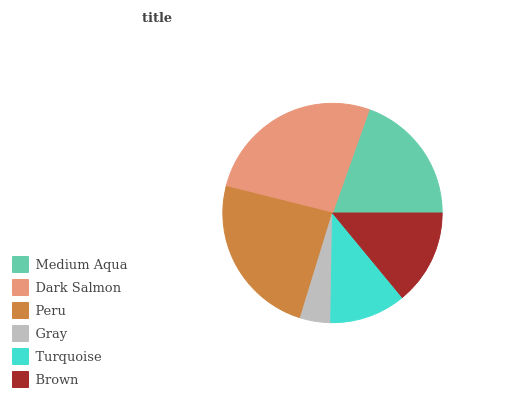Is Gray the minimum?
Answer yes or no. Yes. Is Dark Salmon the maximum?
Answer yes or no. Yes. Is Peru the minimum?
Answer yes or no. No. Is Peru the maximum?
Answer yes or no. No. Is Dark Salmon greater than Peru?
Answer yes or no. Yes. Is Peru less than Dark Salmon?
Answer yes or no. Yes. Is Peru greater than Dark Salmon?
Answer yes or no. No. Is Dark Salmon less than Peru?
Answer yes or no. No. Is Medium Aqua the high median?
Answer yes or no. Yes. Is Brown the low median?
Answer yes or no. Yes. Is Gray the high median?
Answer yes or no. No. Is Turquoise the low median?
Answer yes or no. No. 